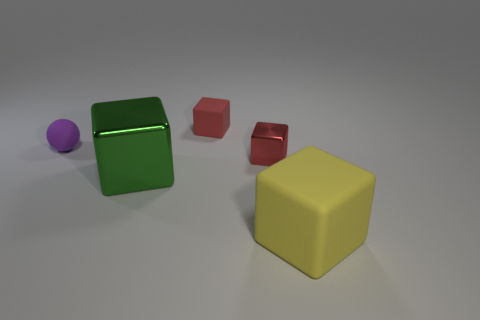Is the number of purple matte balls right of the big green metallic cube the same as the number of cyan matte things?
Your answer should be compact. Yes. What is the color of the tiny cube that is behind the small purple thing?
Make the answer very short. Red. What number of other objects are the same color as the tiny shiny cube?
Keep it short and to the point. 1. Is there anything else that is the same size as the green metallic block?
Make the answer very short. Yes. There is a rubber block in front of the sphere; does it have the same size as the small matte block?
Offer a very short reply. No. There is a big cube that is on the left side of the yellow object; what material is it?
Ensure brevity in your answer.  Metal. Is there anything else that is the same shape as the small red rubber object?
Make the answer very short. Yes. What number of rubber things are small red blocks or large yellow things?
Give a very brief answer. 2. Is the number of tiny rubber balls that are on the right side of the small red rubber object less than the number of things?
Your response must be concise. Yes. What is the shape of the red thing behind the tiny shiny block in front of the small rubber object that is in front of the tiny rubber cube?
Ensure brevity in your answer.  Cube. 